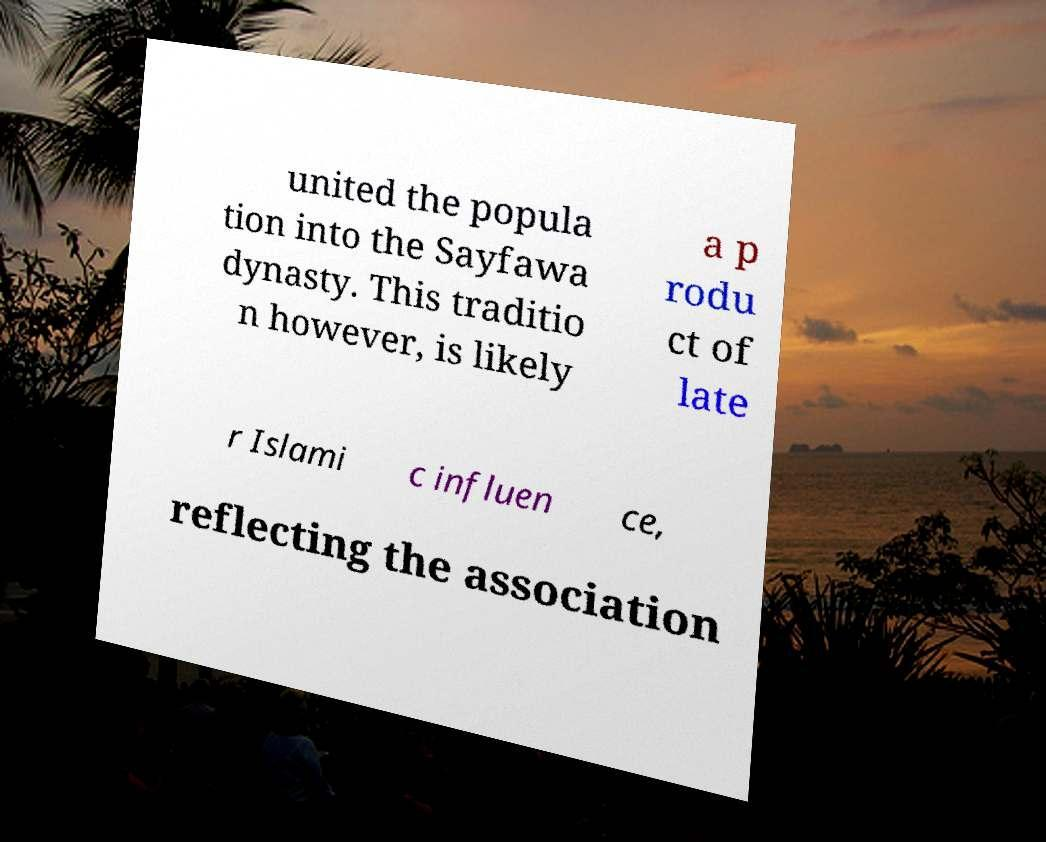I need the written content from this picture converted into text. Can you do that? united the popula tion into the Sayfawa dynasty. This traditio n however, is likely a p rodu ct of late r Islami c influen ce, reflecting the association 